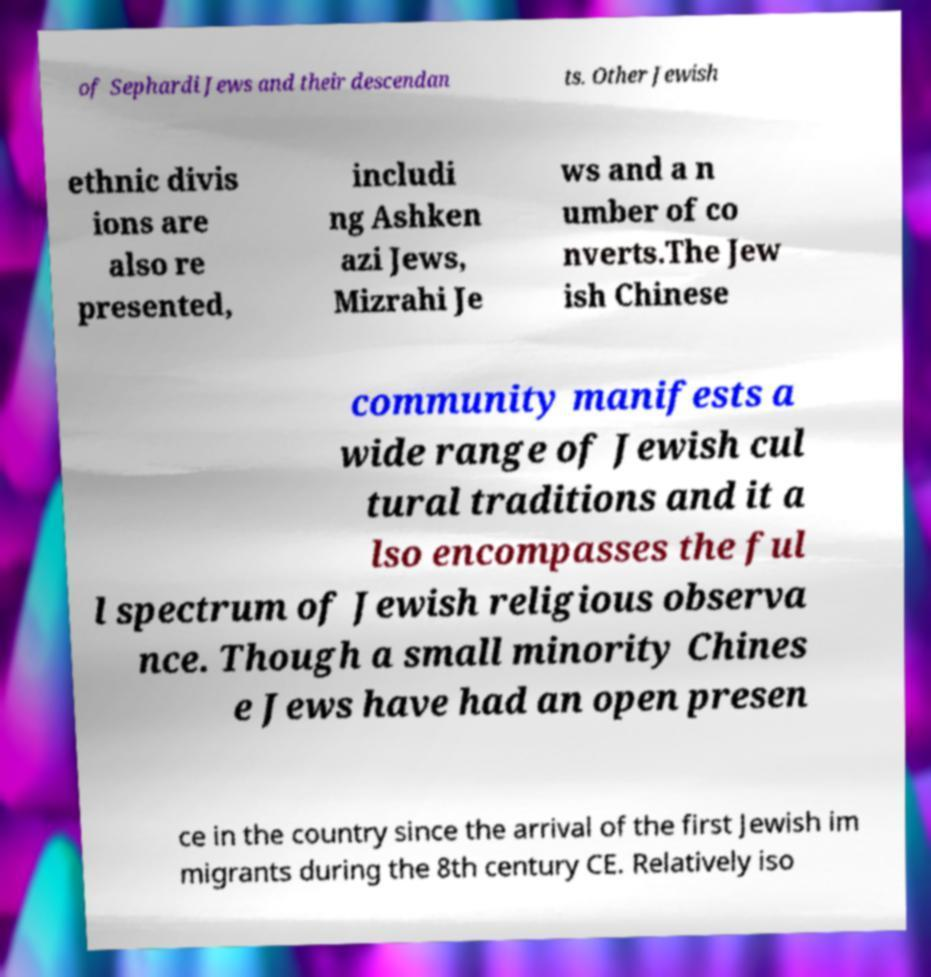I need the written content from this picture converted into text. Can you do that? of Sephardi Jews and their descendan ts. Other Jewish ethnic divis ions are also re presented, includi ng Ashken azi Jews, Mizrahi Je ws and a n umber of co nverts.The Jew ish Chinese community manifests a wide range of Jewish cul tural traditions and it a lso encompasses the ful l spectrum of Jewish religious observa nce. Though a small minority Chines e Jews have had an open presen ce in the country since the arrival of the first Jewish im migrants during the 8th century CE. Relatively iso 